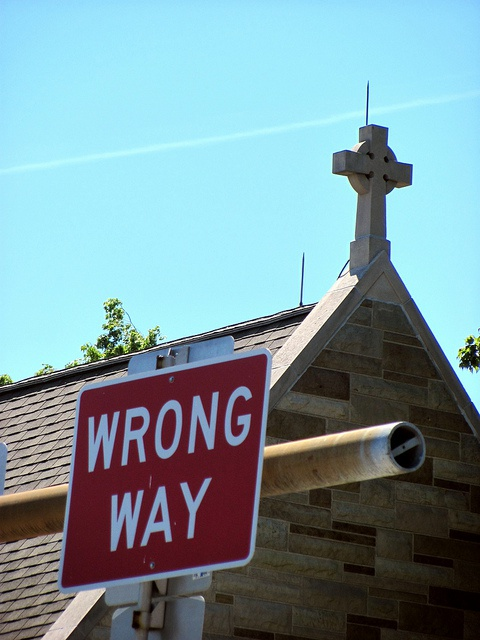Describe the objects in this image and their specific colors. I can see various objects in this image with different colors. 